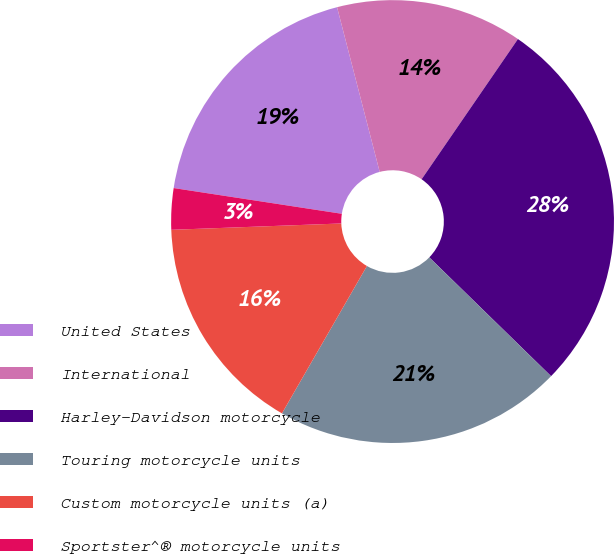Convert chart to OTSL. <chart><loc_0><loc_0><loc_500><loc_500><pie_chart><fcel>United States<fcel>International<fcel>Harley-Davidson motorcycle<fcel>Touring motorcycle units<fcel>Custom motorcycle units (a)<fcel>Sportster^® motorcycle units<nl><fcel>18.55%<fcel>13.61%<fcel>27.72%<fcel>21.02%<fcel>16.08%<fcel>3.01%<nl></chart> 